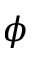<formula> <loc_0><loc_0><loc_500><loc_500>\phi</formula> 